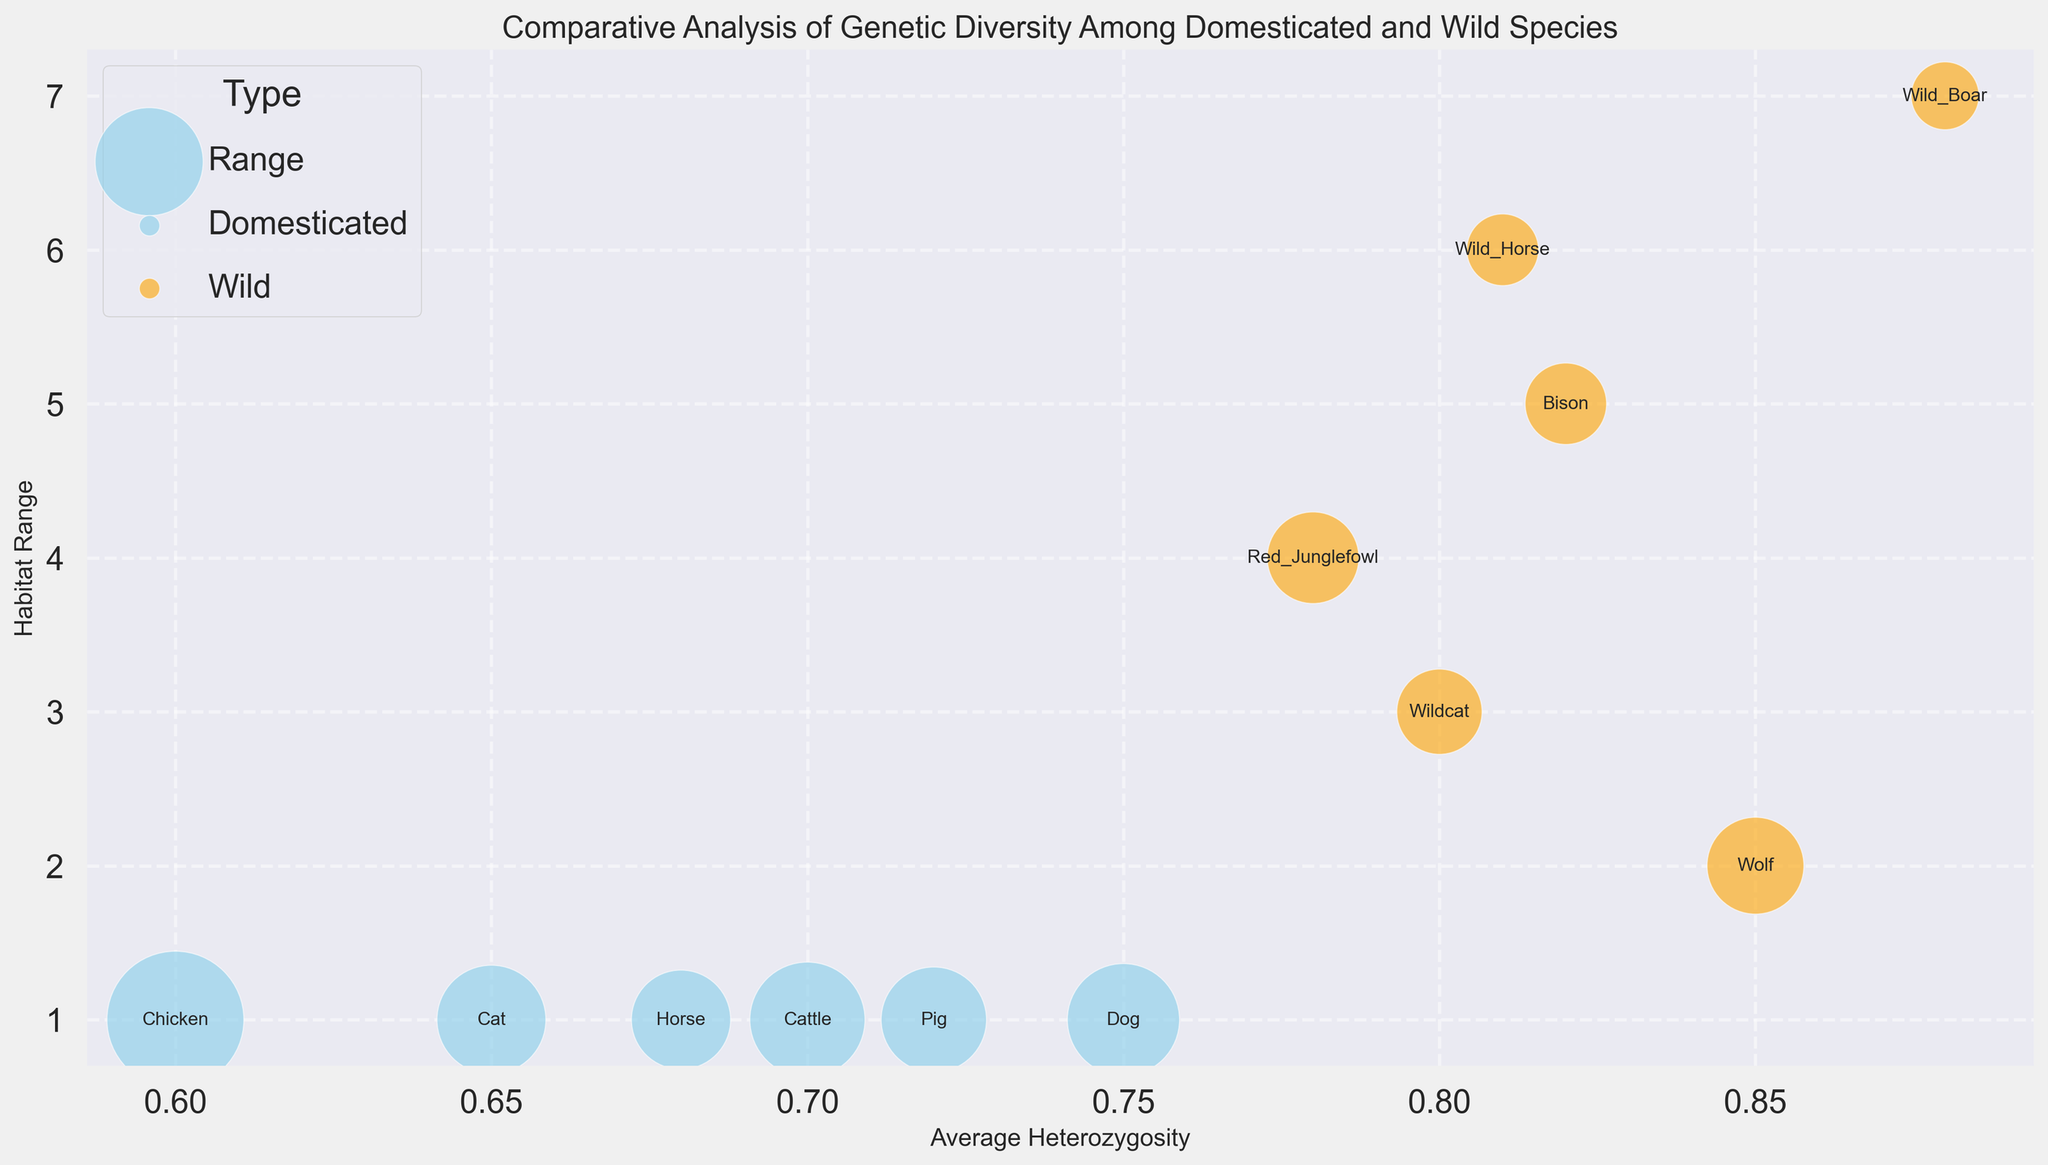Which species shows the highest average heterozygosity? From the bubble chart, look for the species with the bubble positioned farthest to the right on the x-axis (Average Heterozygosity). This corresponds to the Wild Boar with an average heterozygosity of 0.88.
Answer: Wild Boar Which domesticated species has the smallest population size? Check the size of the bubbles corresponding to domesticated species (sky blue color). The smallest bubble size among them represents the Horse with a population size of 55,000.
Answer: Horse What is the habitat range difference between Bison and Chicken? Find the vertical position (Range) of Bison and Chicken. Bison has a range of 5 and Chicken has a range of 1. The difference is calculated as 5 - 1 = 4.
Answer: 4 Which wild species has the smallest population size and what's its average heterozygosity? Identify the smallest bubble among the wild species (orange color), which is the Wild Boar. Then, check its average heterozygosity, which is 0.88.
Answer: Wild Boar, 0.88 How does the genetic diversity of domesticated species compare to wild species on average? Calculate the average heterozygosity for domesticated and wild species. Domesticated species' average heterozygosity: (0.75+0.65+0.70+0.60+0.68+0.72)/6 = 0.683. Wild species' average heterozygosity: (0.85+0.80+0.82+0.78+0.81+0.88)/6 = 0.823. Comparatively, wild species have higher average heterozygosity.
Answer: Wild species have higher genetic diversity Which species inhabit the widest habitat range? Look for the bubble positioned highest on the y-axis (Range). The species with the highest range value is the Wild Boar with a range of 7.
Answer: Wild Boar Which two domesticated species have the closest average heterozygosity values, and what are those values? Find the domesticated species (sky blue) with average heterozygosity values closest to each other. The Dog (0.75) and Pig (0.72) show the closest values.
Answer: Dog (0.75), Pig (0.72) Which species has a larger habitat range, Wildcat or Red Junglefowl? Compare the vertical positions (Range) of Wildcat and Red Junglefowl. Wildcat is higher with a range of 3, while Red Junglefowl has a range of 4.
Answer: Red Junglefowl What is the ratio of the population sizes between the species with the highest genetic diversity and the species with the lowest genetic diversity? The species with the highest average heterozygosity is the Wild Boar (0.88) with a population size of 12,000. The species with the lowest average heterozygosity is the Chicken (0.60) with a population size of 200,000. The ratio is 12,000 / 200,000 = 0.06.
Answer: 0.06 